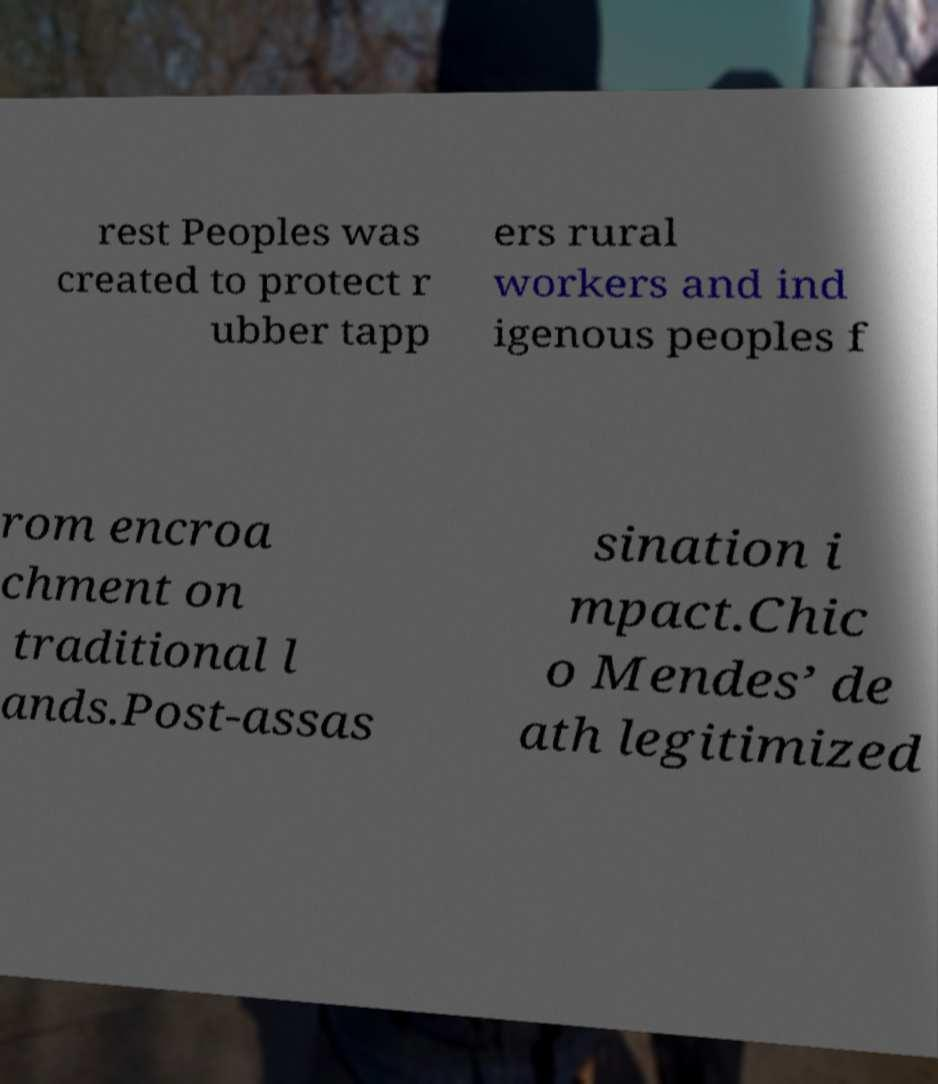Can you accurately transcribe the text from the provided image for me? rest Peoples was created to protect r ubber tapp ers rural workers and ind igenous peoples f rom encroa chment on traditional l ands.Post-assas sination i mpact.Chic o Mendes’ de ath legitimized 